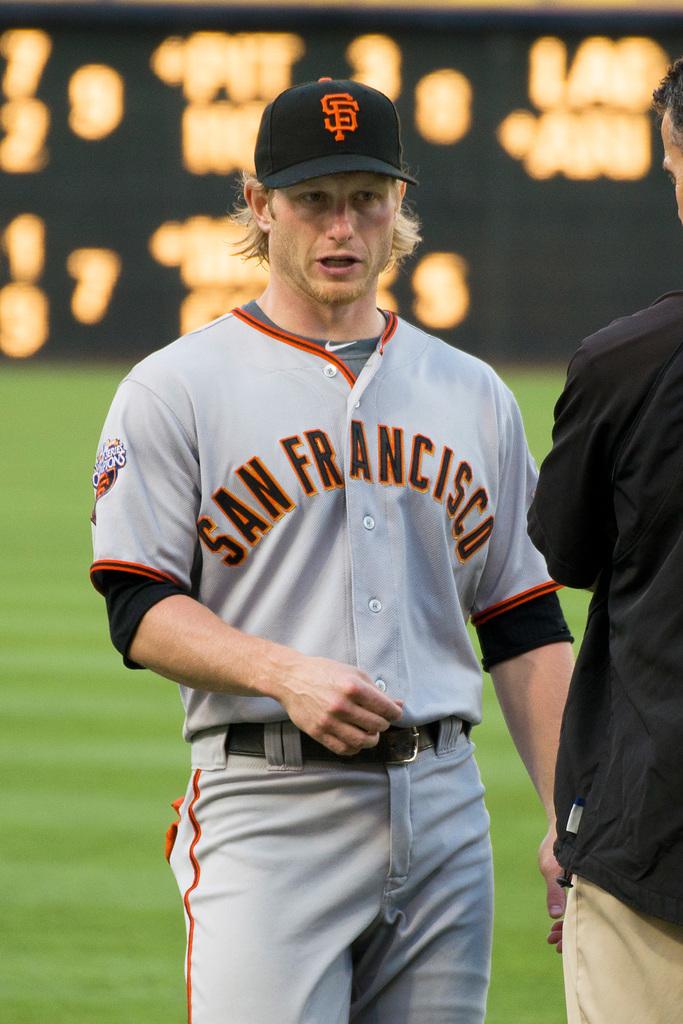What team does this player play for?
Provide a short and direct response. San francisco. What letters are abbreviated on the hat?
Provide a succinct answer. Sf. 